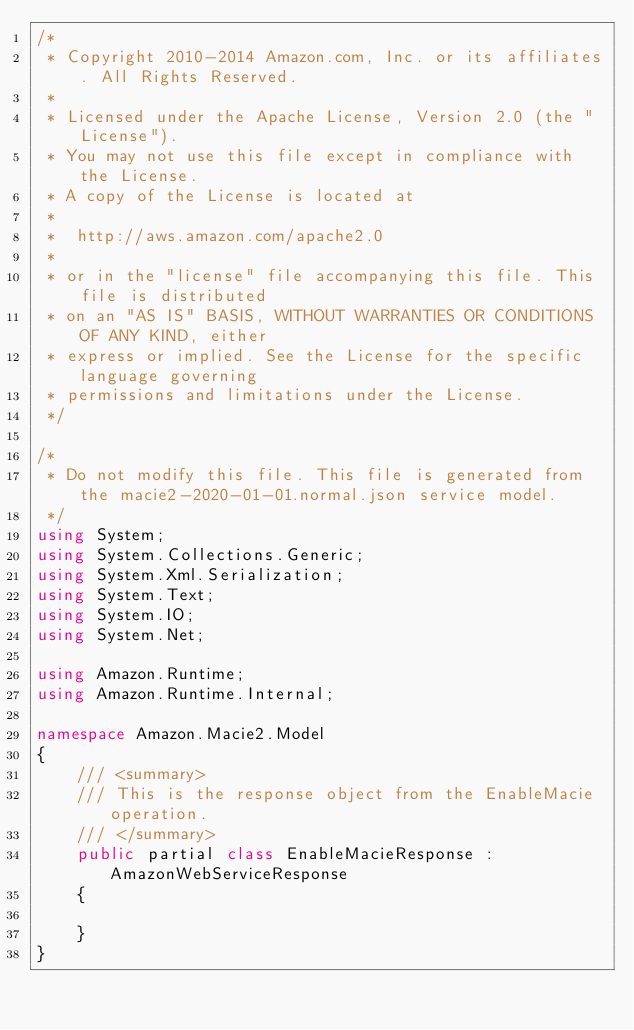Convert code to text. <code><loc_0><loc_0><loc_500><loc_500><_C#_>/*
 * Copyright 2010-2014 Amazon.com, Inc. or its affiliates. All Rights Reserved.
 * 
 * Licensed under the Apache License, Version 2.0 (the "License").
 * You may not use this file except in compliance with the License.
 * A copy of the License is located at
 * 
 *  http://aws.amazon.com/apache2.0
 * 
 * or in the "license" file accompanying this file. This file is distributed
 * on an "AS IS" BASIS, WITHOUT WARRANTIES OR CONDITIONS OF ANY KIND, either
 * express or implied. See the License for the specific language governing
 * permissions and limitations under the License.
 */

/*
 * Do not modify this file. This file is generated from the macie2-2020-01-01.normal.json service model.
 */
using System;
using System.Collections.Generic;
using System.Xml.Serialization;
using System.Text;
using System.IO;
using System.Net;

using Amazon.Runtime;
using Amazon.Runtime.Internal;

namespace Amazon.Macie2.Model
{
    /// <summary>
    /// This is the response object from the EnableMacie operation.
    /// </summary>
    public partial class EnableMacieResponse : AmazonWebServiceResponse
    {

    }
}</code> 